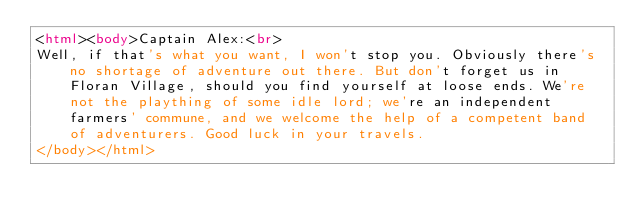Convert code to text. <code><loc_0><loc_0><loc_500><loc_500><_HTML_><html><body>Captain Alex:<br>
Well, if that's what you want, I won't stop you. Obviously there's no shortage of adventure out there. But don't forget us in Floran Village, should you find yourself at loose ends. We're not the plaything of some idle lord; we're an independent farmers' commune, and we welcome the help of a competent band of adventurers. Good luck in your travels.
</body></html></code> 